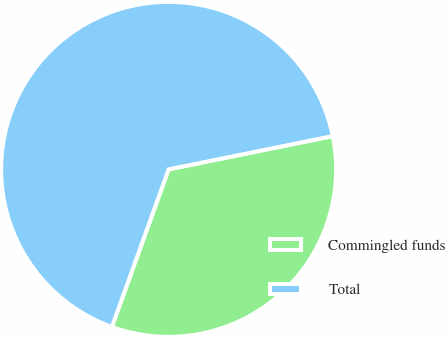Convert chart. <chart><loc_0><loc_0><loc_500><loc_500><pie_chart><fcel>Commingled funds<fcel>Total<nl><fcel>33.69%<fcel>66.31%<nl></chart> 